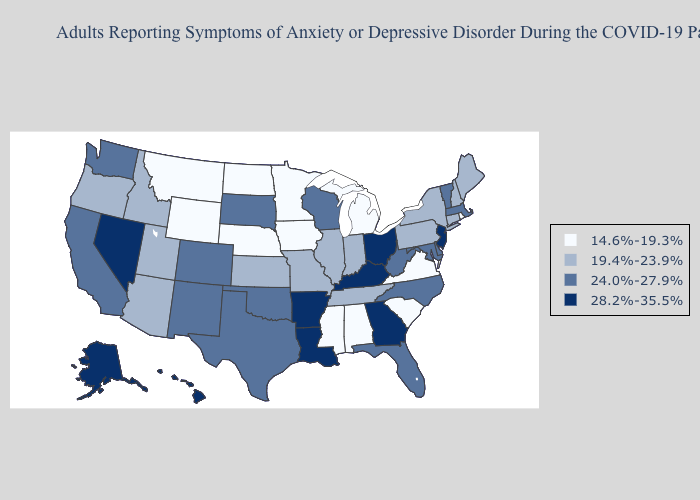What is the value of Georgia?
Short answer required. 28.2%-35.5%. Name the states that have a value in the range 14.6%-19.3%?
Short answer required. Alabama, Iowa, Michigan, Minnesota, Mississippi, Montana, Nebraska, North Dakota, Rhode Island, South Carolina, Virginia, Wyoming. What is the highest value in the Northeast ?
Write a very short answer. 28.2%-35.5%. Does Mississippi have the lowest value in the USA?
Be succinct. Yes. Name the states that have a value in the range 24.0%-27.9%?
Be succinct. California, Colorado, Delaware, Florida, Maryland, Massachusetts, New Mexico, North Carolina, Oklahoma, South Dakota, Texas, Vermont, Washington, West Virginia, Wisconsin. Name the states that have a value in the range 19.4%-23.9%?
Concise answer only. Arizona, Connecticut, Idaho, Illinois, Indiana, Kansas, Maine, Missouri, New Hampshire, New York, Oregon, Pennsylvania, Tennessee, Utah. Name the states that have a value in the range 19.4%-23.9%?
Answer briefly. Arizona, Connecticut, Idaho, Illinois, Indiana, Kansas, Maine, Missouri, New Hampshire, New York, Oregon, Pennsylvania, Tennessee, Utah. Is the legend a continuous bar?
Keep it brief. No. Name the states that have a value in the range 14.6%-19.3%?
Short answer required. Alabama, Iowa, Michigan, Minnesota, Mississippi, Montana, Nebraska, North Dakota, Rhode Island, South Carolina, Virginia, Wyoming. Name the states that have a value in the range 19.4%-23.9%?
Quick response, please. Arizona, Connecticut, Idaho, Illinois, Indiana, Kansas, Maine, Missouri, New Hampshire, New York, Oregon, Pennsylvania, Tennessee, Utah. Does Arkansas have the lowest value in the USA?
Give a very brief answer. No. Name the states that have a value in the range 19.4%-23.9%?
Short answer required. Arizona, Connecticut, Idaho, Illinois, Indiana, Kansas, Maine, Missouri, New Hampshire, New York, Oregon, Pennsylvania, Tennessee, Utah. Name the states that have a value in the range 19.4%-23.9%?
Be succinct. Arizona, Connecticut, Idaho, Illinois, Indiana, Kansas, Maine, Missouri, New Hampshire, New York, Oregon, Pennsylvania, Tennessee, Utah. Name the states that have a value in the range 19.4%-23.9%?
Give a very brief answer. Arizona, Connecticut, Idaho, Illinois, Indiana, Kansas, Maine, Missouri, New Hampshire, New York, Oregon, Pennsylvania, Tennessee, Utah. What is the highest value in the South ?
Answer briefly. 28.2%-35.5%. 